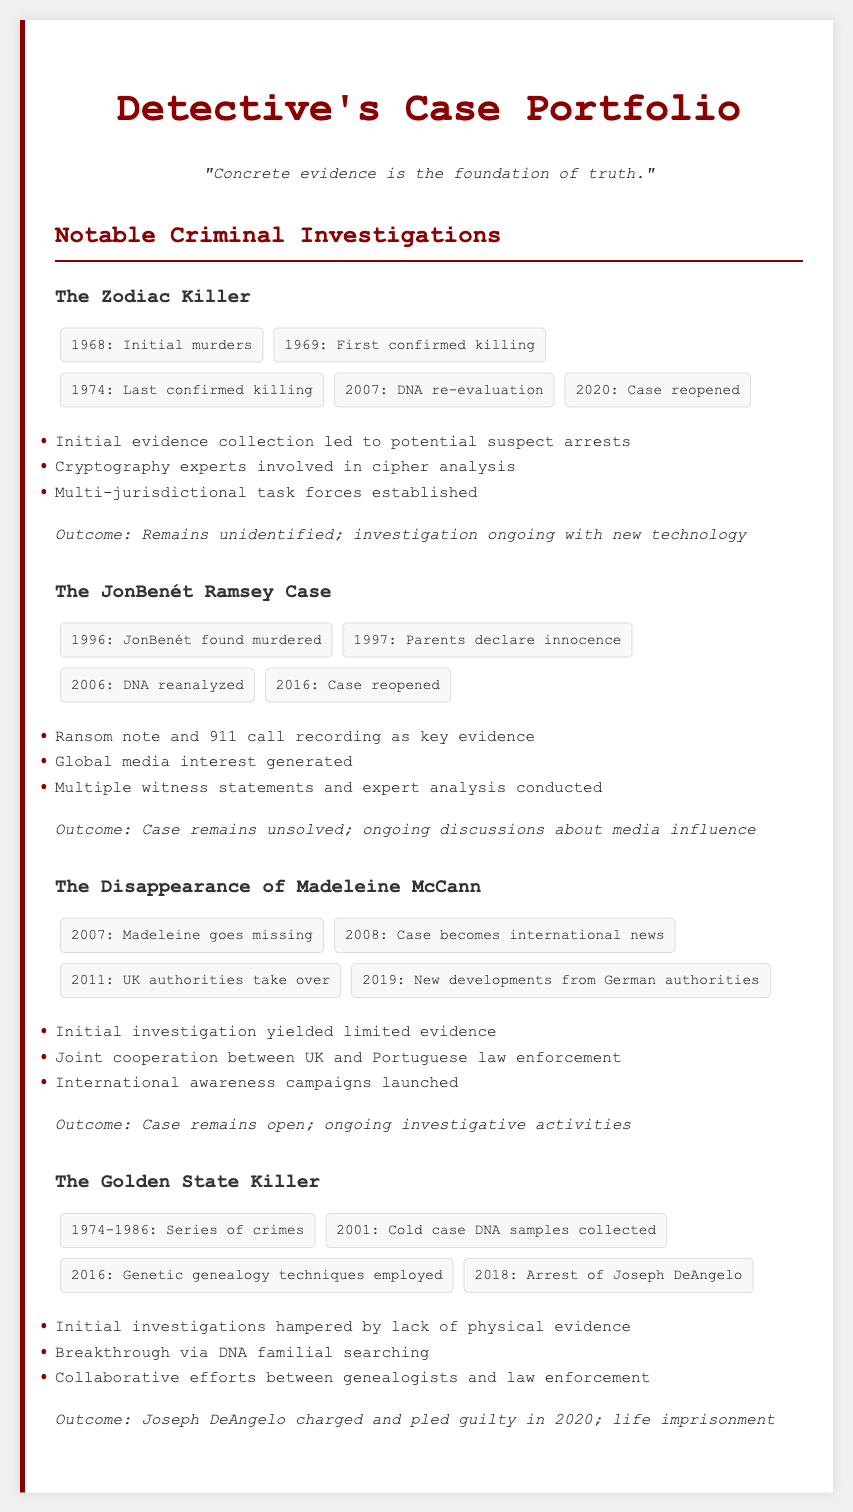What year was JonBenét found murdered? The document states that JonBenét was found murdered in 1996.
Answer: 1996 What is the outcome of the Zodiac Killer investigation? The outcome mentioned indicates that the Zodiac Killer remains unidentified and the investigation is ongoing with new technology.
Answer: Remains unidentified; investigation ongoing What year did the Golden State Killer get arrested? According to the timeline, Joseph DeAngelo was arrested in 2018.
Answer: 2018 What key evidence was highlighted in the JonBenét Ramsey Case? The document points out that the ransom note and 911 call recording were key pieces of evidence in the case.
Answer: Ransom note and 911 call recording What technique was employed in the investigation of the Golden State Killer? The timeline states that genetic genealogy techniques were employed during the investigation.
Answer: Genetic genealogy techniques How many years did the series of crimes attributed to the Golden State Killer span? The timeline indicates that the series of crimes occurred from 1974 to 1986, which amounts to 12 years.
Answer: 12 years When was the case of Madeleine McCann opened by UK authorities? It is stated that UK authorities took over the case in 2011.
Answer: 2011 What prompted the reopening of the JonBenét Ramsey Case in 2016? The document reflects that the case was reopened in 2016 after a re-analysis of evidence.
Answer: Case reopened What international action was taken in the disappearance of Madeleine McCann? The document mentions that international awareness campaigns were launched.
Answer: International awareness campaigns 